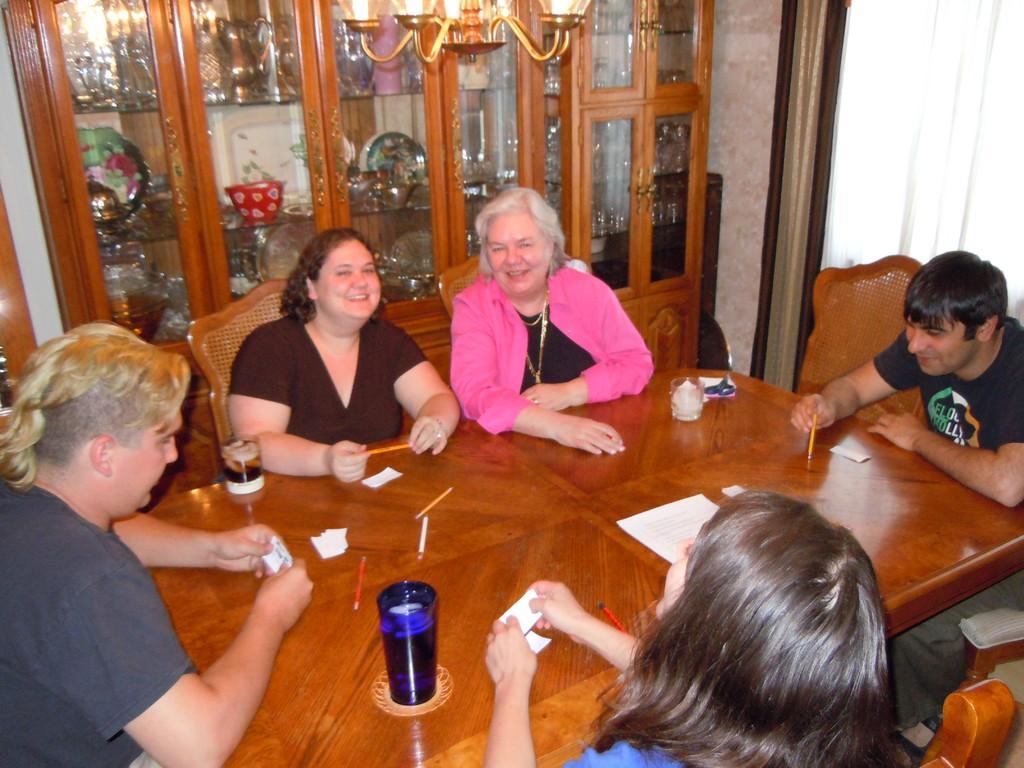In one or two sentences, can you explain what this image depicts? In this image I can see there are group of people who are sitting on a chair in front of the table. On the table we have couple of objects like pen, glass and other things on it. I can also see there is a chandelier and a glass shelf. 